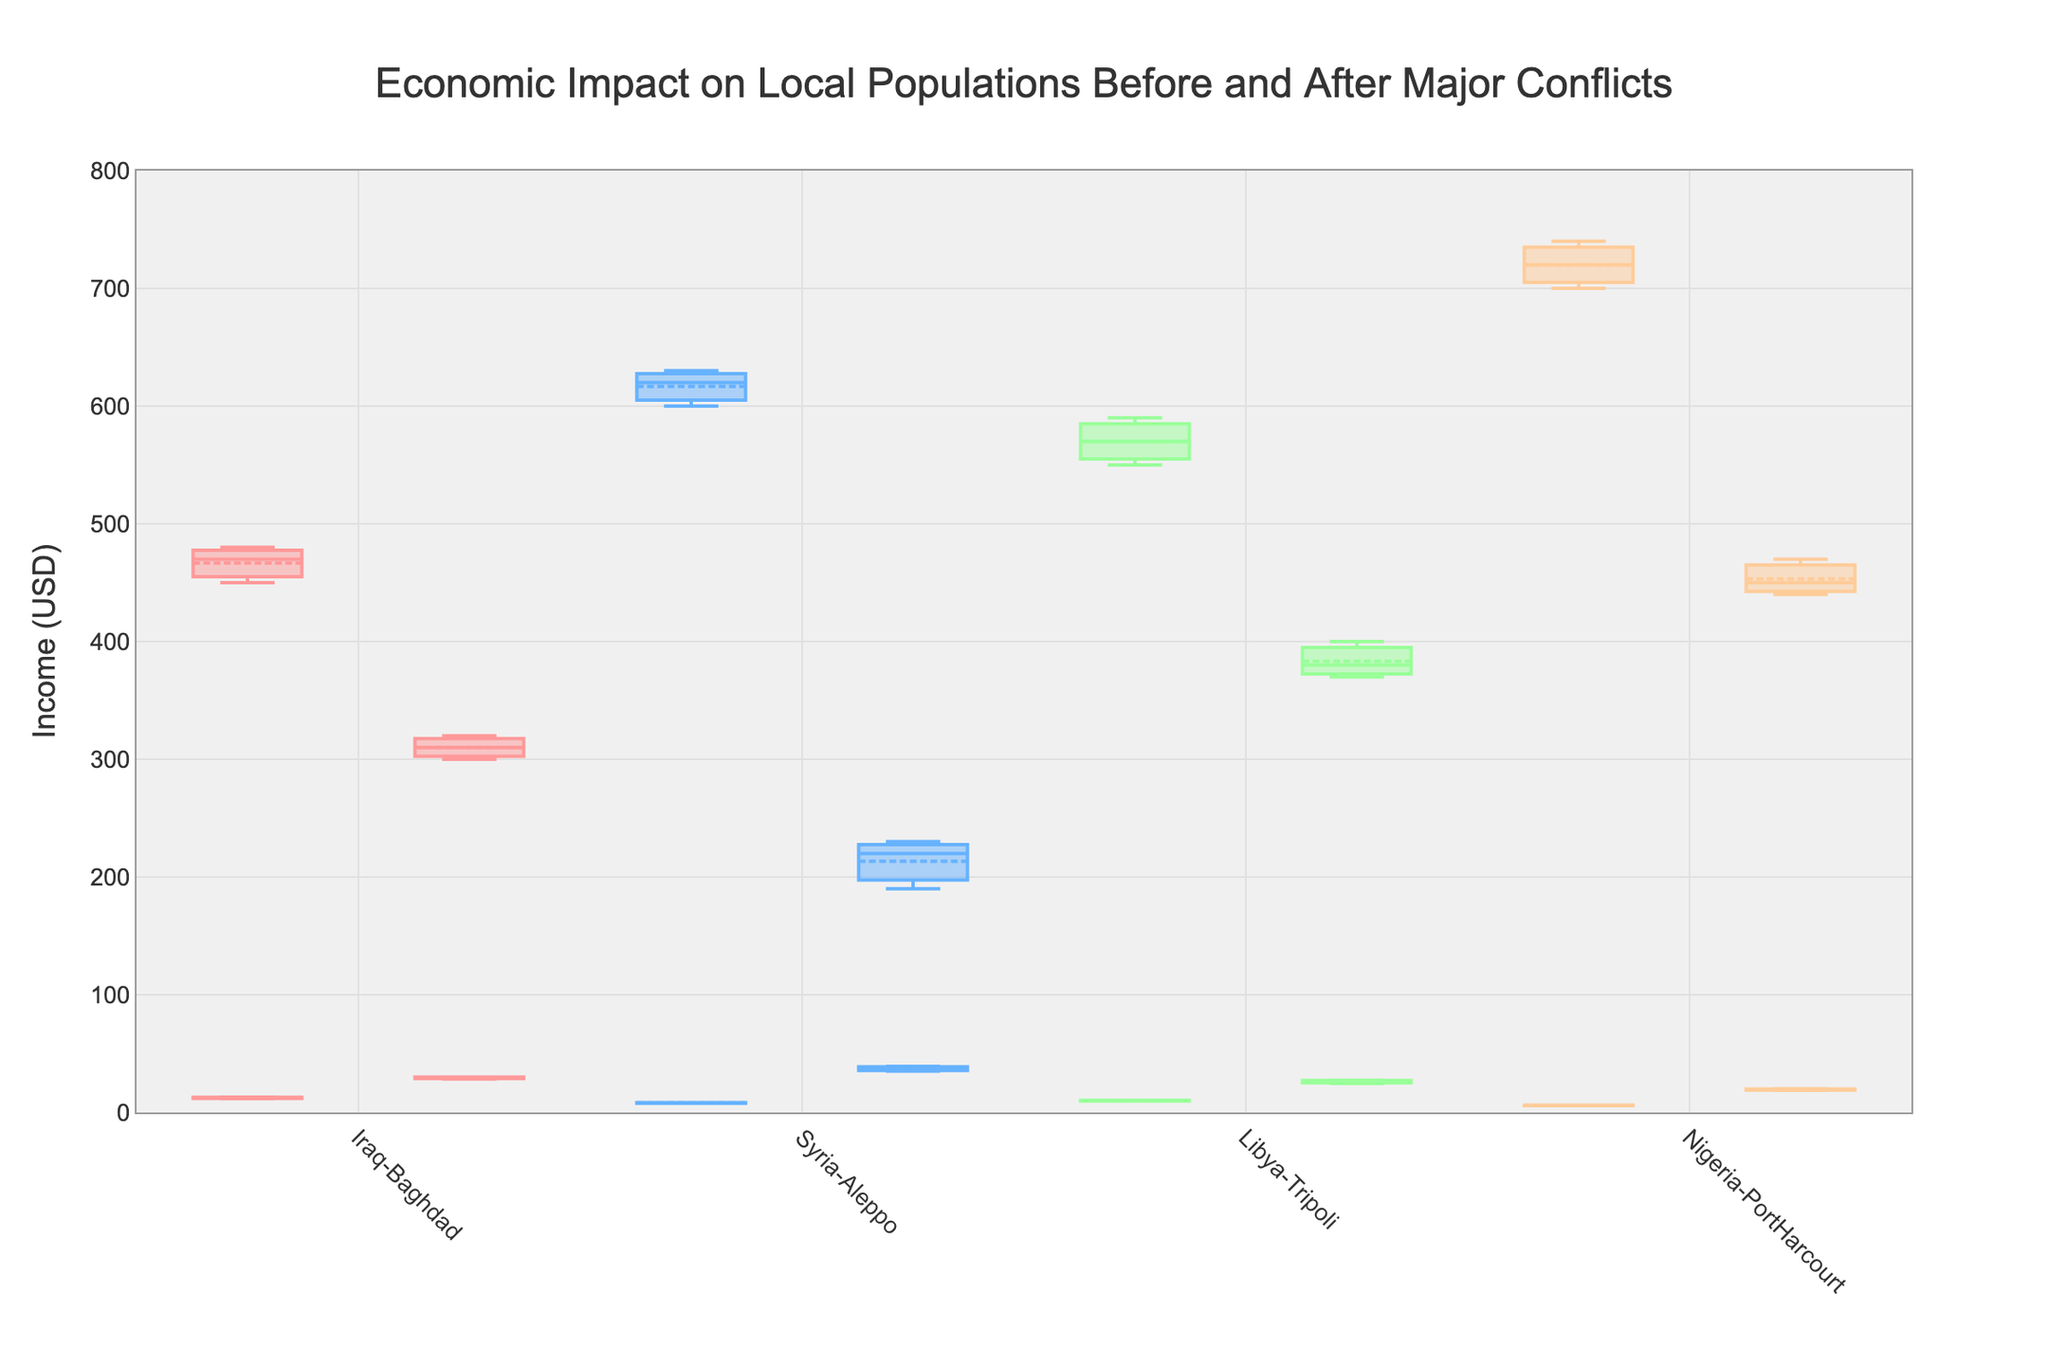What is the range of Income for Iraq-Baghdad before the conflict? The box plot for Iraq-Baghdad before the conflict shows the income values, with the bottom and top of the box representing the 25th and 75th percentiles, respectively. The minimum income before the conflict in Iraq-Baghdad is 450 and the maximum is 480. So, the range is the difference between the highest and lowest values.
Answer: 30 How did the Unemployment Rate change in Syria-Aleppo after the conflict? To answer this, we look at the median values of the unemployment rate box plots for Syria-Aleppo. Before the conflict, the median unemployment rate is around 8, and after the conflict, the median is approximately 36. The change is the difference between these two values.
Answer: Around 28% Which location had the highest median Income before the conflict? By comparing the median lines in the income box plots for each location before the conflict: Nigeria-PortHarcourt shows the highest median income, around 720.
Answer: Nigeria-PortHarcourt Which location experienced the largest increase in median unemployment rates after the conflict? Compare the increases in median unemployment rates for each location by looking at the difference in median lines before and after conflicts. Syria-Aleppo's unemployment rate increased the most, from around 8 to around 37, which is a difference of about 29.
Answer: Syria-Aleppo What was the median Income in Libya-Tripoli after the conflict? The median is represented by the line inside the box in the relevant box plot. For Libya-Tripoli after the conflict, the median income is marked around 380-390 USD.
Answer: 380-390 USD How did the Income distribution change in Nigeria-PortHarcourt after the conflict compared to before? Examine the spread of the box plots for Income in Nigeria-PortHarcourt before and after the conflict. Before, the interquartile range (IQR) is between 700-740 USD, while after, it is between 440-470 USD. The median also shifted from around 720 to approximately 450. Both the median and IQR decreased significantly after the conflict.
Answer: Median decreased from 720 to 450, IQR became smaller Which location had the highest unemployment rate increase in percentage points after the conflict? Look at the difference in median unemployment rate values before and after conflicts for each location. Syria-Aleppo increased from about 8% to about 37%, a jump of 29 percentage points, which is the largest increase among the locations shown.
Answer: Syria-Aleppo 